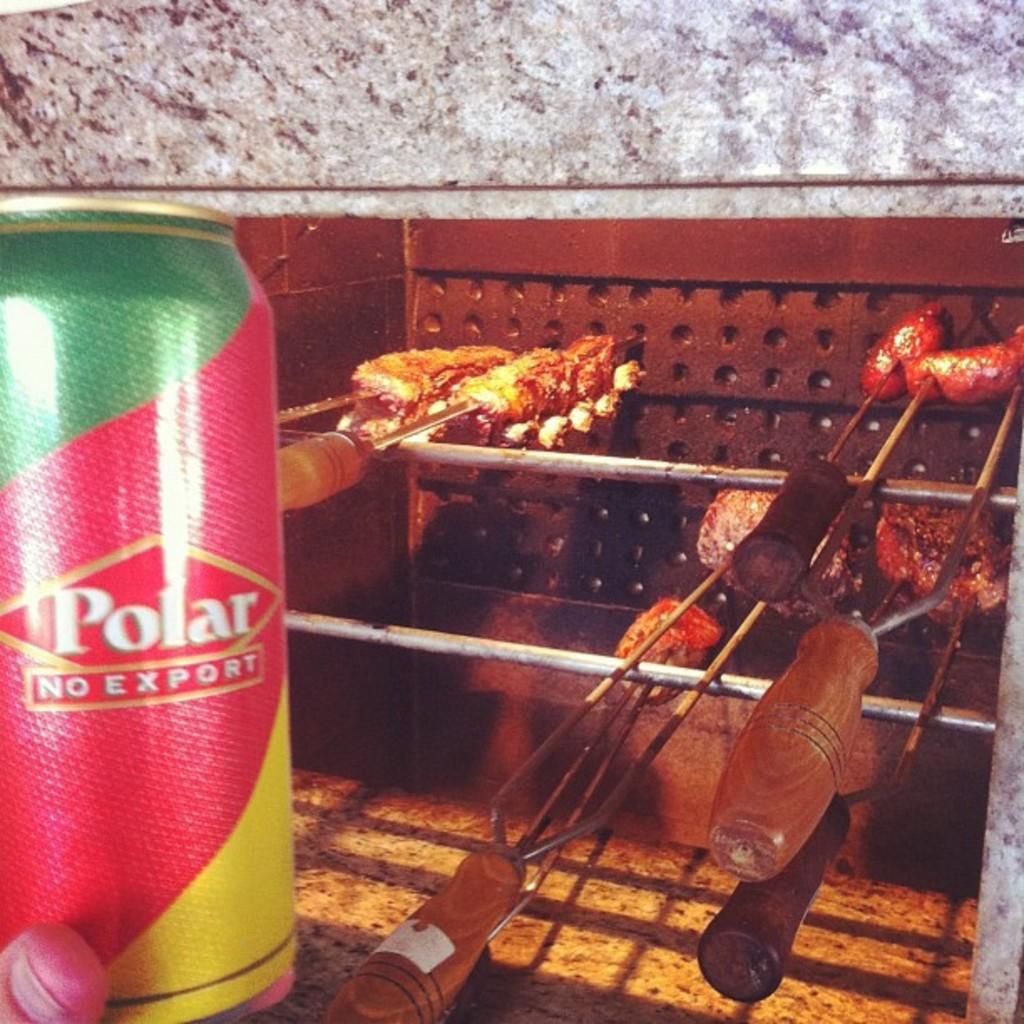Could you give a brief overview of what you see in this image? In this picture I can observe meat in the middle of the picture. On the left side there is a tin which is in green, red and yellow colors. In the background there is a wall. 